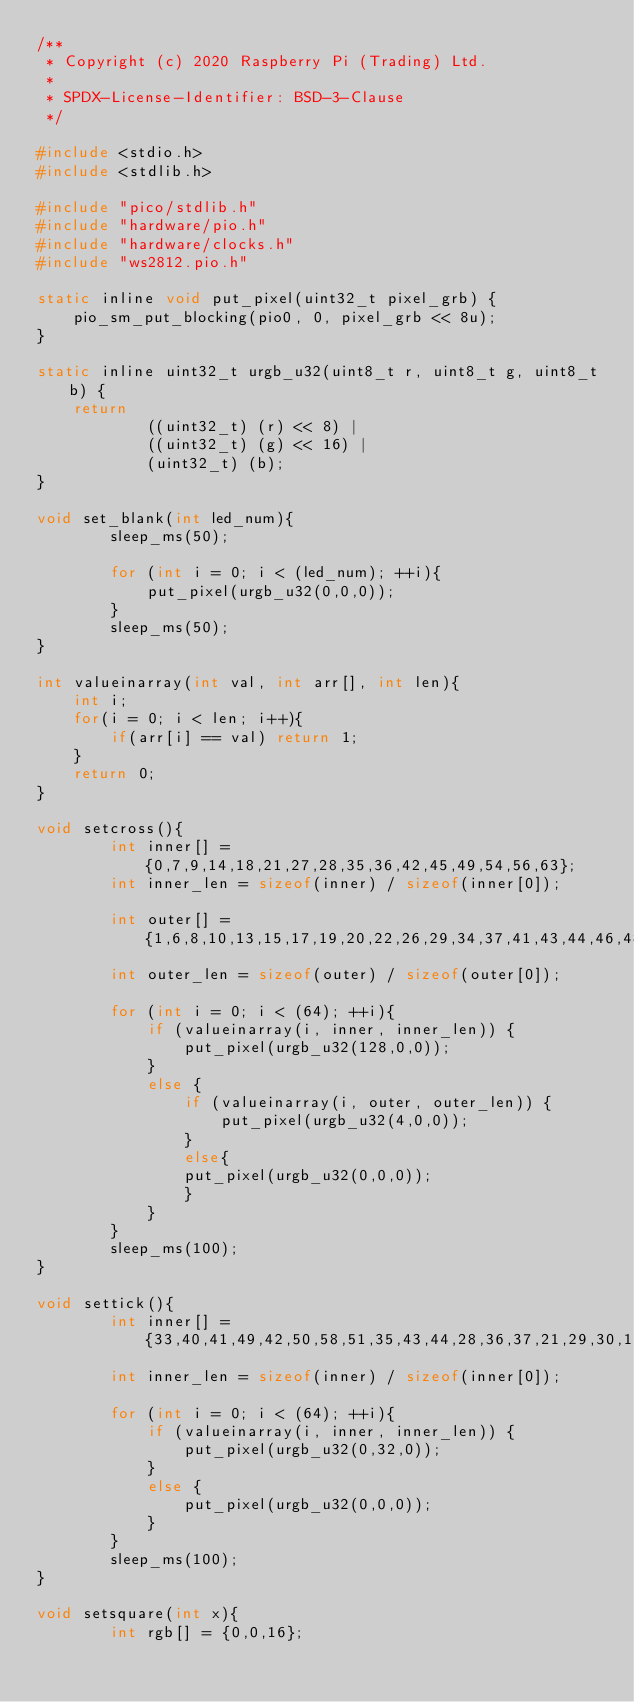Convert code to text. <code><loc_0><loc_0><loc_500><loc_500><_C_>/**
 * Copyright (c) 2020 Raspberry Pi (Trading) Ltd.
 *
 * SPDX-License-Identifier: BSD-3-Clause
 */

#include <stdio.h>
#include <stdlib.h>

#include "pico/stdlib.h"
#include "hardware/pio.h"
#include "hardware/clocks.h"
#include "ws2812.pio.h"

static inline void put_pixel(uint32_t pixel_grb) {
    pio_sm_put_blocking(pio0, 0, pixel_grb << 8u);
}

static inline uint32_t urgb_u32(uint8_t r, uint8_t g, uint8_t b) {
    return
            ((uint32_t) (r) << 8) |
            ((uint32_t) (g) << 16) |
            (uint32_t) (b);
}

void set_blank(int led_num){
		sleep_ms(50);

		for (int i = 0; i < (led_num); ++i){
			put_pixel(urgb_u32(0,0,0));
		}
		sleep_ms(50);
}

int valueinarray(int val, int arr[], int len){
    int i;
    for(i = 0; i < len; i++){
        if(arr[i] == val) return 1;
    }
    return 0;
}

void setcross(){
		int inner[] = {0,7,9,14,18,21,27,28,35,36,42,45,49,54,56,63};
		int inner_len = sizeof(inner) / sizeof(inner[0]);

		int outer[] = {1,6,8,10,13,15,17,19,20,22,26,29,34,37,41,43,44,46,48,50,53,55,57,62};
		int outer_len = sizeof(outer) / sizeof(outer[0]);

		for (int i = 0; i < (64); ++i){
			if (valueinarray(i, inner, inner_len)) {
				put_pixel(urgb_u32(128,0,0));
			}
			else {
				if (valueinarray(i, outer, outer_len)) {
					put_pixel(urgb_u32(4,0,0));
				}
				else{
				put_pixel(urgb_u32(0,0,0));
				}
			}
		}
		sleep_ms(100);
}

void settick(){
		int inner[] = {33,40,41,49,42,50,58,51,35,43,44,28,36,37,21,29,30,14,22,23,7,15};
		int inner_len = sizeof(inner) / sizeof(inner[0]);

		for (int i = 0; i < (64); ++i){
			if (valueinarray(i, inner, inner_len)) {
				put_pixel(urgb_u32(0,32,0));
			}
			else {
				put_pixel(urgb_u32(0,0,0));
			}
		}
		sleep_ms(100);
}

void setsquare(int x){
		int rgb[] = {0,0,16};
</code> 